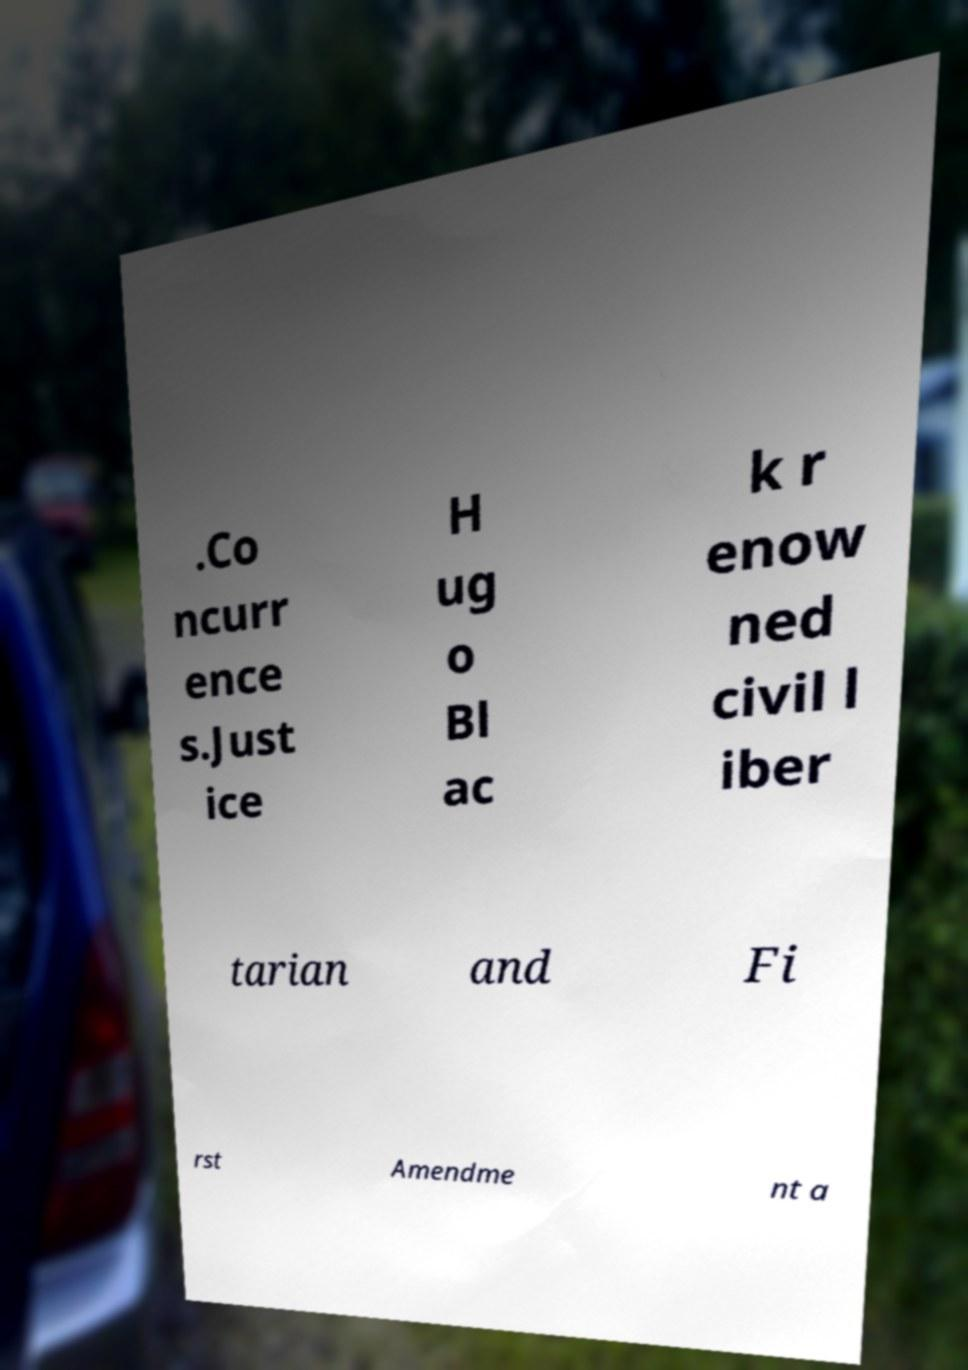For documentation purposes, I need the text within this image transcribed. Could you provide that? .Co ncurr ence s.Just ice H ug o Bl ac k r enow ned civil l iber tarian and Fi rst Amendme nt a 